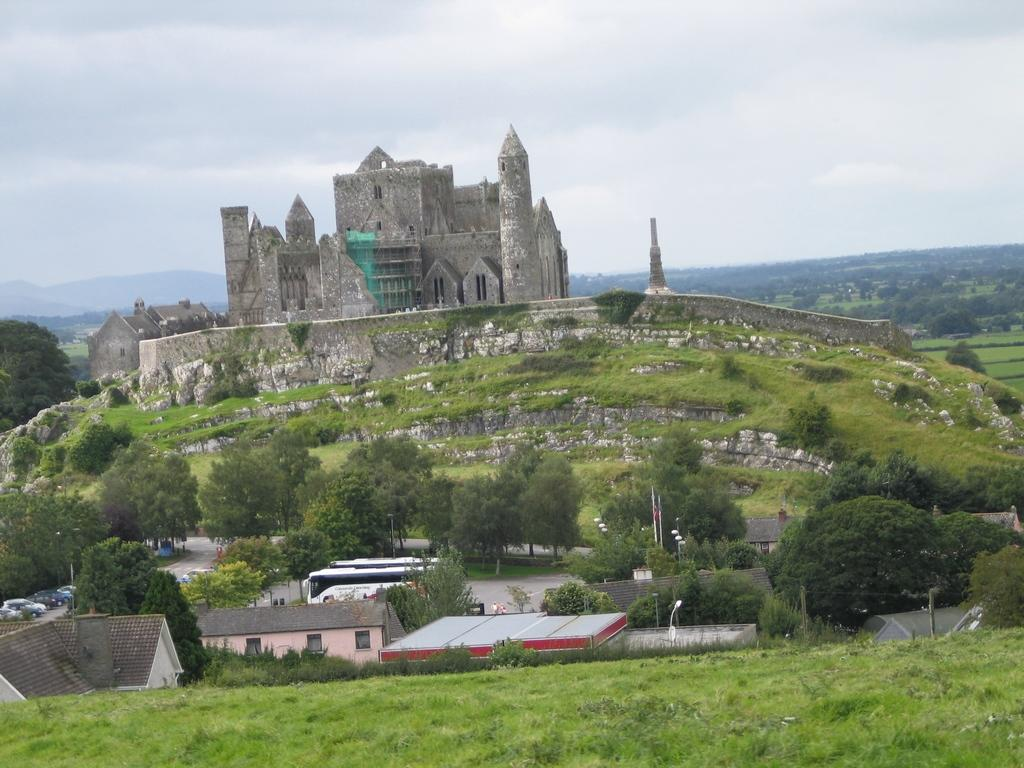What type of structures can be seen in the image? There are houses and a fort in the image. What are some other objects visible in the image? There are light poles, trees, vehicles, and mountains in the image. What is the color of the sky in the image? The sky is in white and blue color. Where is the appliance located in the image? There is no appliance present in the image. What type of tray can be seen on the side of the fort? There is no tray visible on the side of the fort or anywhere else in the image. 